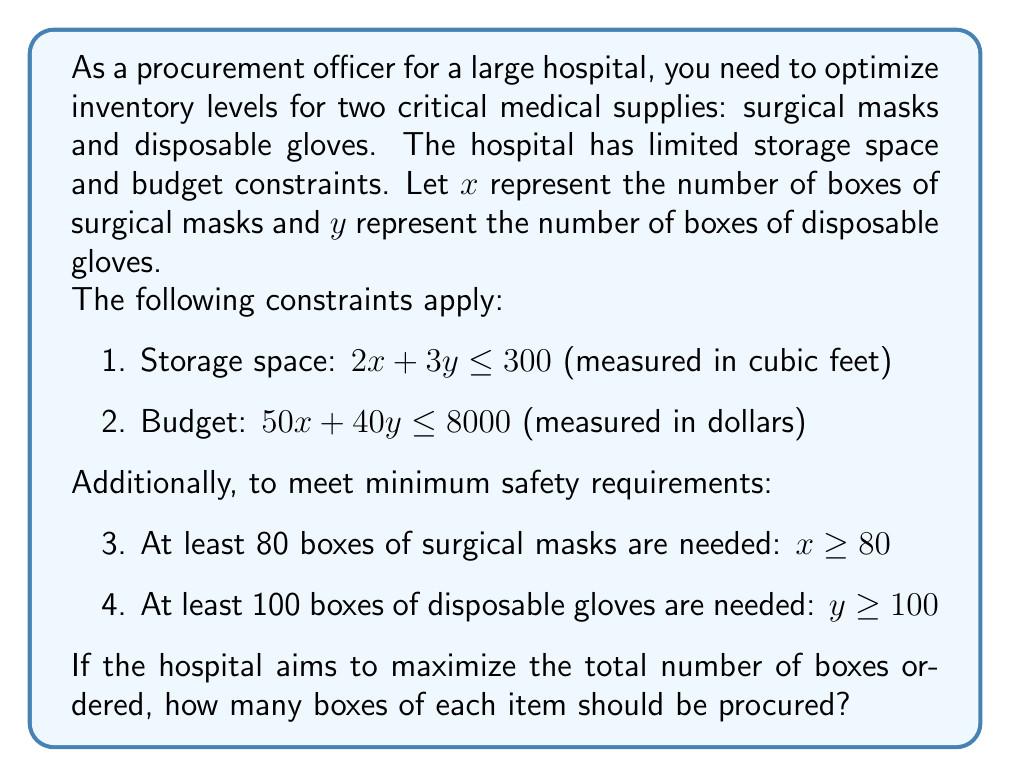Provide a solution to this math problem. To solve this problem, we'll use a system of linear equations and the concept of linear programming. We need to maximize $x + y$ subject to the given constraints.

Step 1: Identify the constraints
1. $2x + 3y \leq 300$
2. $50x + 40y \leq 8000$
3. $x \geq 80$
4. $y \geq 100$

Step 2: Plot the constraints
We can visualize these constraints on a coordinate plane, but we'll solve algebraically.

Step 3: Find the intersection points of the constraints
Let's find the intersection of constraints 1 and 2:

$2x + 3y = 300$ ... (1)
$50x + 40y = 8000$ ... (2)

Multiply (1) by 25: $50x + 75y = 7500$
Subtract this from (2): $-35y = 500$
$y = -\frac{500}{35} \approx 14.29$

This y-value doesn't satisfy constraint 4, so we can disregard it.

Step 4: Check the corner points
The feasible region is bounded by the four constraints. The optimal solution will be at one of the corner points. Let's find these points:

a) Intersection of $x = 80$ and $y = 100$: (80, 100)
b) Intersection of $2x + 3y = 300$ and $y = 100$:
   $2x + 300 = 300$
   $x = 0$ (not feasible)
c) Intersection of $50x + 40y = 8000$ and $y = 100$:
   $50x + 4000 = 8000$
   $x = 80$
d) Intersection of $2x + 3y = 300$ and $50x + 40y = 8000$:
   We found earlier that this point is not feasible.

Step 5: Evaluate the objective function $(x + y)$ at the feasible corner points
(80, 100): $80 + 100 = 180$
(80, 100): $80 + 100 = 180$ (same point)

Therefore, the optimal solution is to order 80 boxes of surgical masks and 100 boxes of disposable gloves.
Answer: The hospital should procure 80 boxes of surgical masks and 100 boxes of disposable gloves to maximize the total number of boxes ordered while satisfying all constraints. 